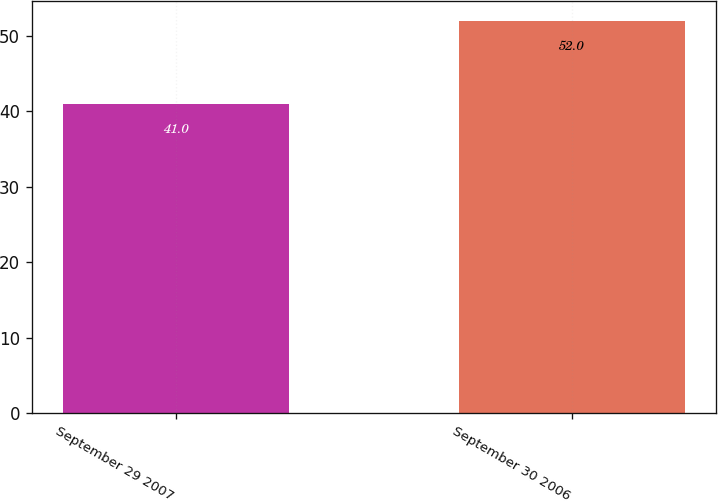<chart> <loc_0><loc_0><loc_500><loc_500><bar_chart><fcel>September 29 2007<fcel>September 30 2006<nl><fcel>41<fcel>52<nl></chart> 